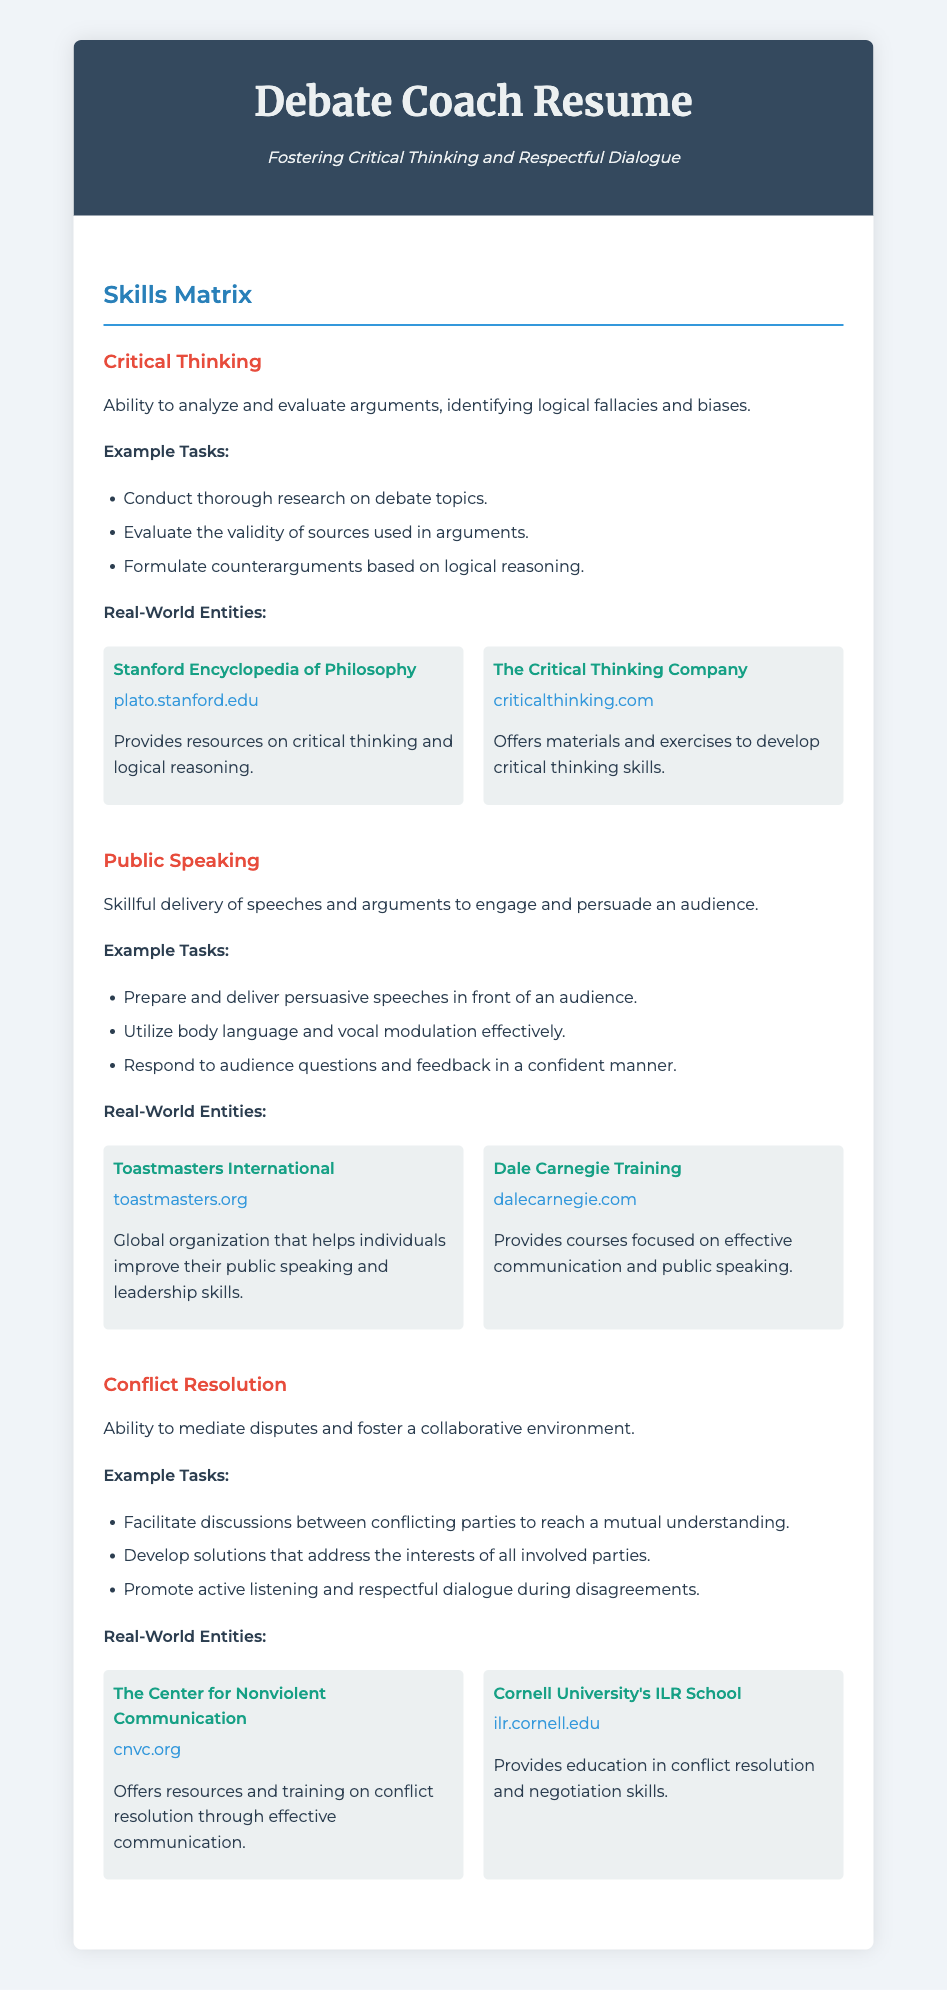What is the subtitle of the resume? The subtitle is given directly under the main title, indicating the focus of the resume.
Answer: Fostering Critical Thinking and Respectful Dialogue How many main skills are highlighted in the Skills Matrix? The document outlines three specific skills in the Skills Matrix section.
Answer: Three What is the first example task listed under Critical Thinking? The first task under Critical Thinking is a specific action describing a skill requirement.
Answer: Conduct thorough research on debate topics Which organization is associated with public speaking improvement? The resume mentions a well-known organization dedicated to enhancing public speaking skills.
Answer: Toastmasters International What does the conflict resolution skill emphasize as a need in discussions? The description of the conflict resolution skill highlights an essential attitude for mediation.
Answer: Active listening What resource is provided for critical thinking? The document lists a notable online encyclopedia that serves as a resource for improving critical thinking skills.
Answer: Stanford Encyclopedia of Philosophy How is public speaking described in terms of audience engagement? The definition supplied in the document highlights a significant aspect of effective public speaking.
Answer: Engage and persuade an audience What type of organization is Dale Carnegie Training? The document classifies this entity focused on communication skills training.
Answer: Course provider 